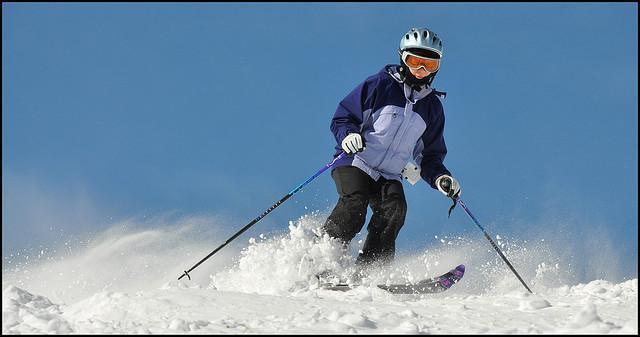How many people are there?
Give a very brief answer. 1. 